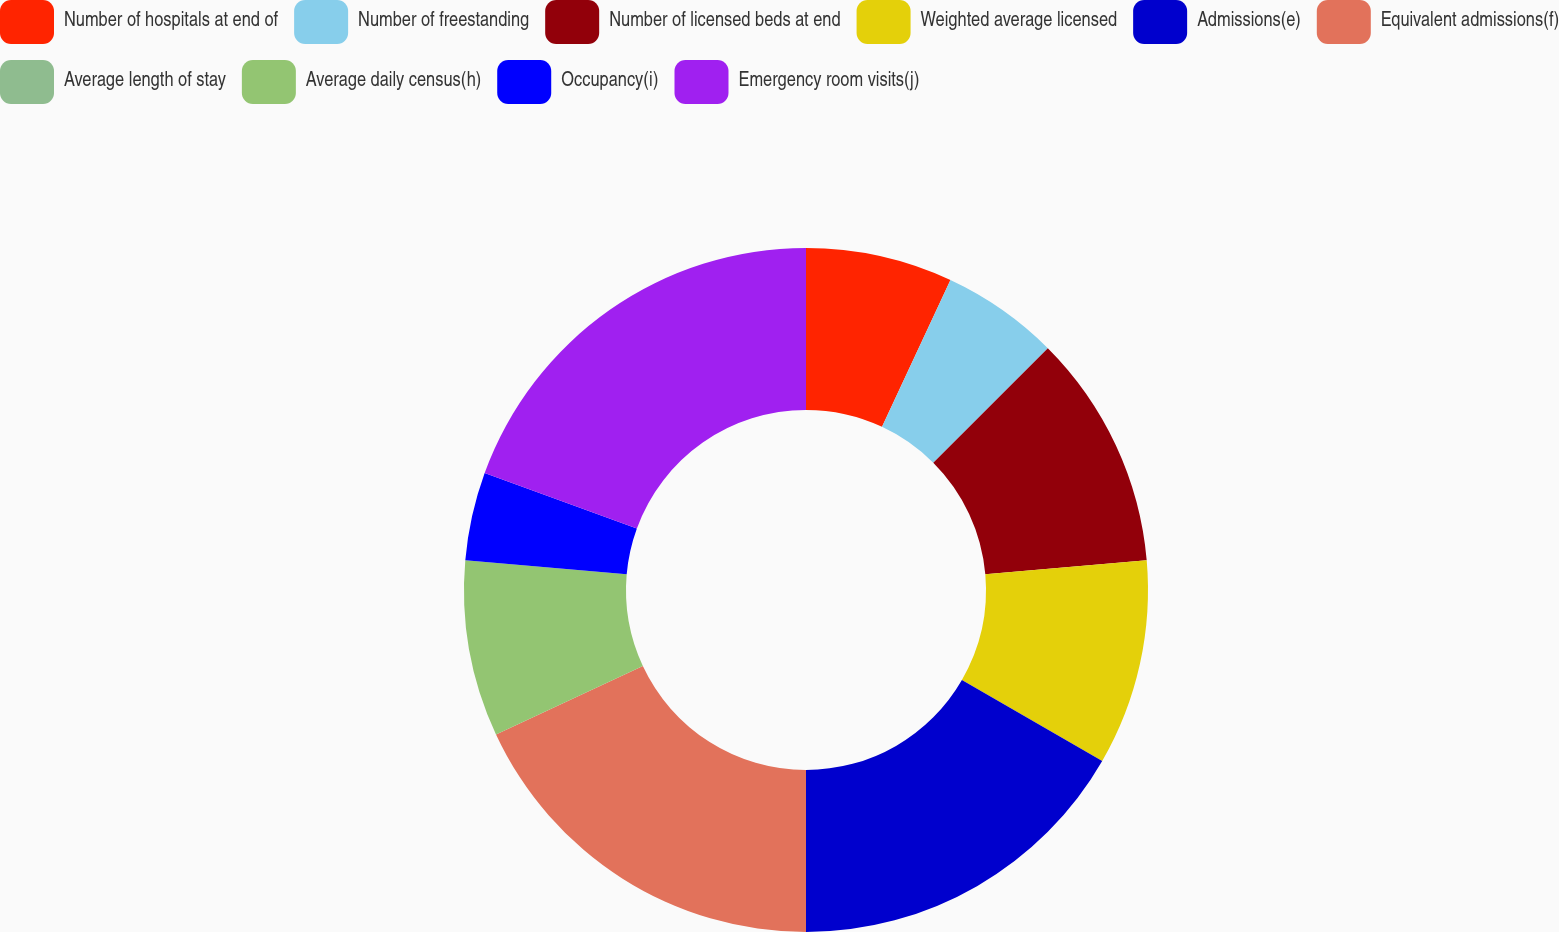Convert chart to OTSL. <chart><loc_0><loc_0><loc_500><loc_500><pie_chart><fcel>Number of hospitals at end of<fcel>Number of freestanding<fcel>Number of licensed beds at end<fcel>Weighted average licensed<fcel>Admissions(e)<fcel>Equivalent admissions(f)<fcel>Average length of stay<fcel>Average daily census(h)<fcel>Occupancy(i)<fcel>Emergency room visits(j)<nl><fcel>6.94%<fcel>5.56%<fcel>11.11%<fcel>9.72%<fcel>16.67%<fcel>18.06%<fcel>0.0%<fcel>8.33%<fcel>4.17%<fcel>19.44%<nl></chart> 